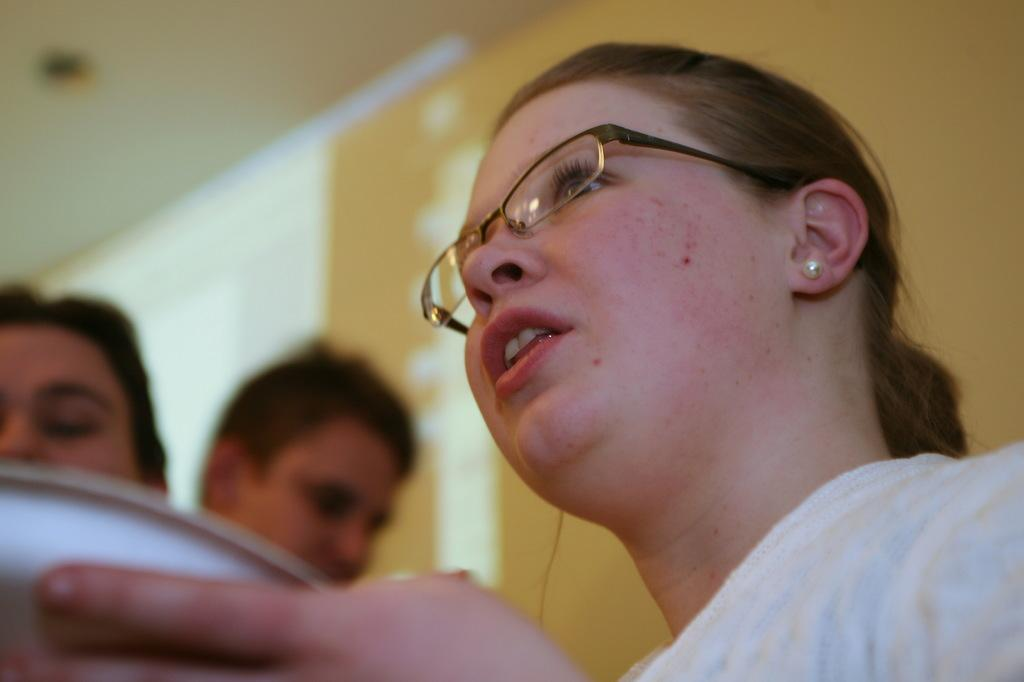Who is the main subject in the image? There is a woman in the image. What is the woman holding in the image? The woman is holding something. Can you describe the people in the background of the image? There are two persons in the background of the image. How would you describe the background of the image? The background of the image is blurry. What type of letter is the cat holding in the image? There is no cat or letter present in the image. 